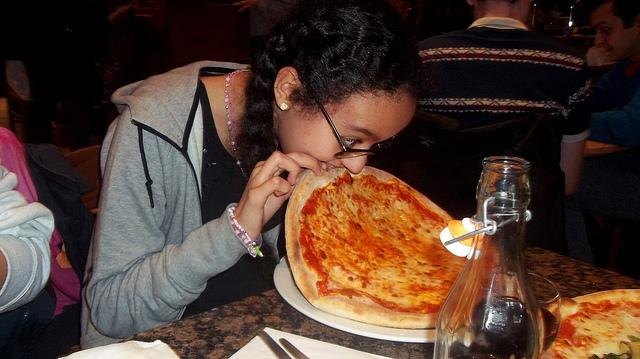What direction are the stripes on the person's shirt going? Please explain your reasoning. horizontal. They are parallel to the floor on the sweater in the background which means they are horizontal. 